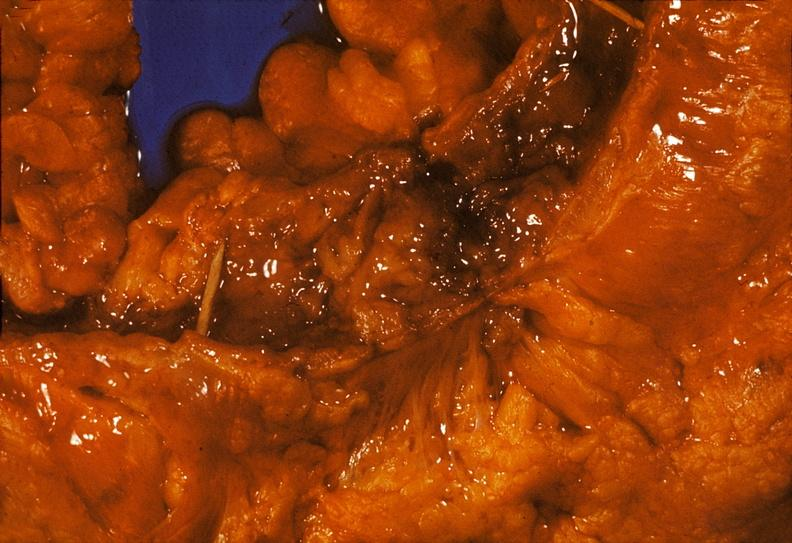what does this image show?
Answer the question using a single word or phrase. Colon 